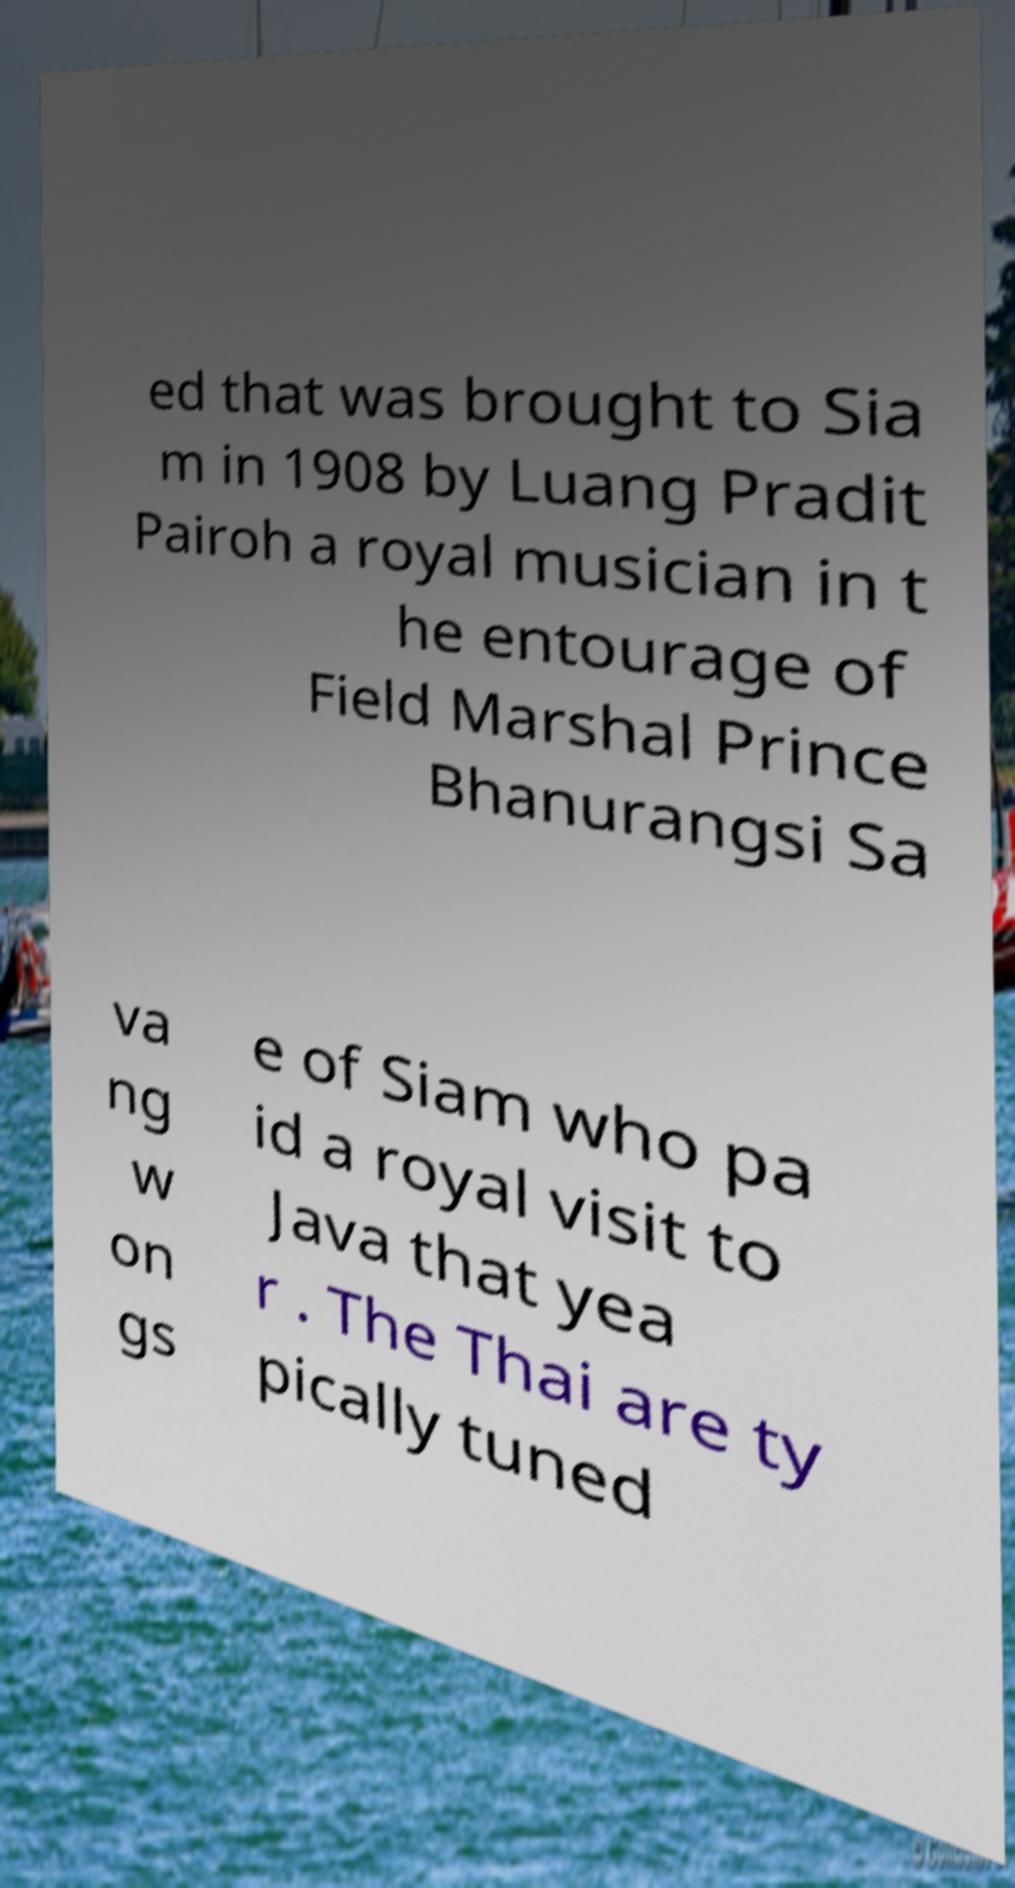Could you assist in decoding the text presented in this image and type it out clearly? ed that was brought to Sia m in 1908 by Luang Pradit Pairoh a royal musician in t he entourage of Field Marshal Prince Bhanurangsi Sa va ng w on gs e of Siam who pa id a royal visit to Java that yea r . The Thai are ty pically tuned 